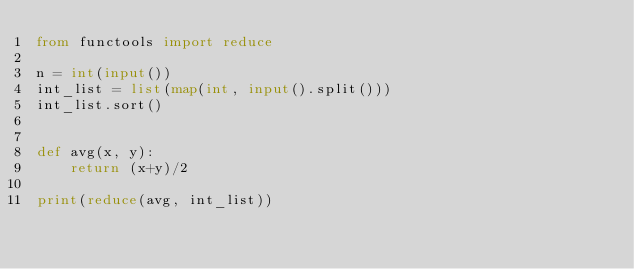<code> <loc_0><loc_0><loc_500><loc_500><_Python_>from functools import reduce

n = int(input())
int_list = list(map(int, input().split()))
int_list.sort()


def avg(x, y):
    return (x+y)/2

print(reduce(avg, int_list))</code> 